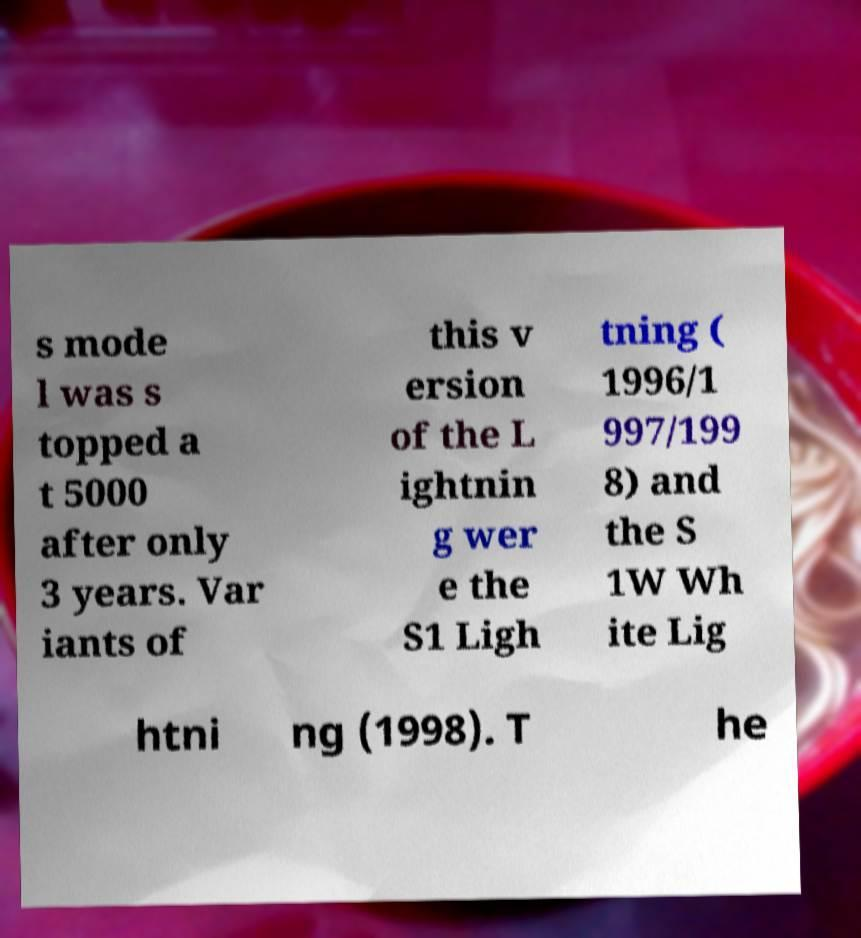For documentation purposes, I need the text within this image transcribed. Could you provide that? s mode l was s topped a t 5000 after only 3 years. Var iants of this v ersion of the L ightnin g wer e the S1 Ligh tning ( 1996/1 997/199 8) and the S 1W Wh ite Lig htni ng (1998). T he 